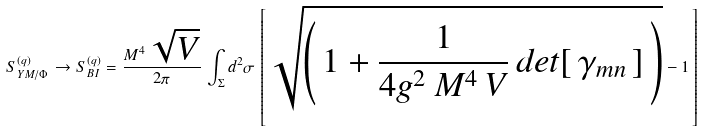<formula> <loc_0><loc_0><loc_500><loc_500>S ^ { ( q ) } _ { Y M / \Phi \, } \to S ^ { ( q ) } _ { B I \, } = \frac { M ^ { 4 } \, \sqrt { V } } { 2 \pi } \, \int _ { \Sigma } d ^ { 2 } \sigma \, \left [ \, \sqrt { \left ( \, 1 + \frac { 1 } { 4 g ^ { 2 } \, M ^ { 4 } \, V } \, d e t [ \, \gamma _ { m n } \, ] \, \right ) } - 1 \, \right ]</formula> 